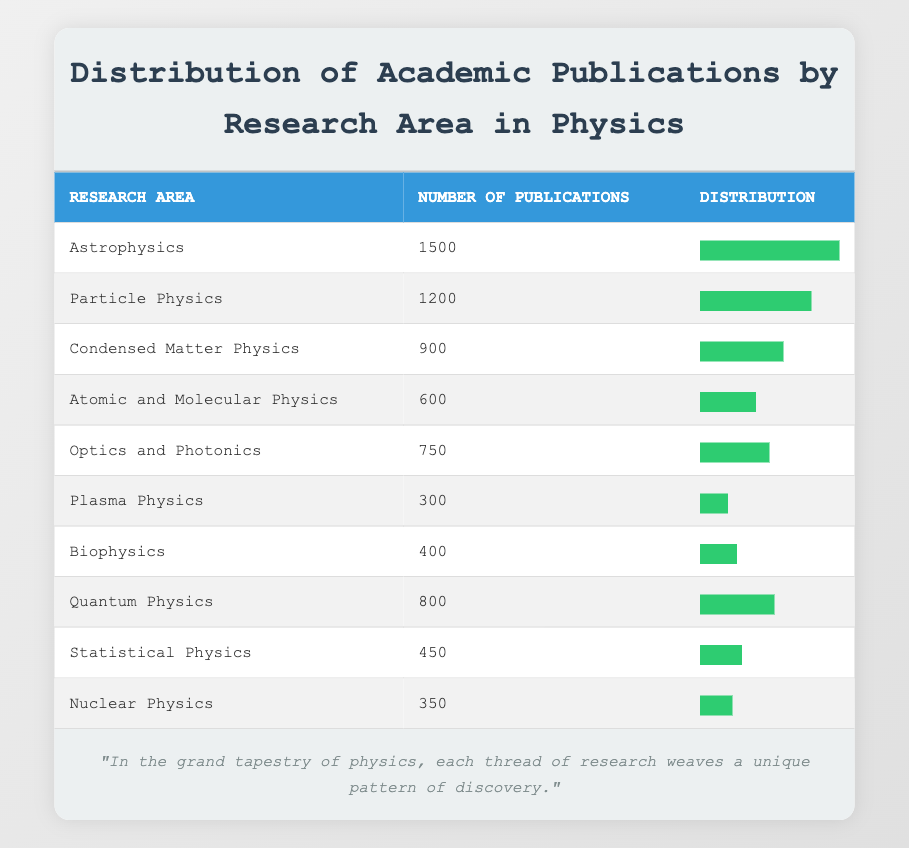What is the research area with the highest number of publications? The table clearly lists the research areas along with their publication numbers. Looking at the data, Astrophysics has 1500 publications, which is the highest compared to other areas.
Answer: Astrophysics How many publications does Nuclear Physics have? The table shows that Nuclear Physics has 350 publications listed in the second column corresponding to its research area.
Answer: 350 What is the total number of publications in the areas of Quantum Physics and Atomic and Molecular Physics? To find the total, we add the number of publications in Quantum Physics (800) and Atomic and Molecular Physics (600). So, 800 + 600 = 1400.
Answer: 1400 Is there more research in Particle Physics than in Plasma Physics? Particle Physics has 1200 publications, while Plasma Physics has only 300. Since 1200 is greater than 300, the statement is true.
Answer: Yes What is the average number of publications across the ten research areas listed? First, sum the number of publications for all areas: 1500 + 1200 + 900 + 600 + 750 + 300 + 400 + 800 + 450 + 350 = 6650. Then divide by the number of areas (10): 6650 / 10 = 665.
Answer: 665 Which research area has the least number of publications? The table shows Plasma Physics with 300 publications as the least compared to the others.
Answer: Plasma Physics Does the number of publications in Biophysics exceed 400? The table indicates that Biophysics has 400 publications, which does not exceed 400, so the answer is that the statement is false.
Answer: No What are the total publications in Condensed Matter Physics and Quantum Physics combined? We add the publications for Condensed Matter Physics (900) and Quantum Physics (800): 900 + 800 = 1700.
Answer: 1700 Which research area has a publication number that is less than the average publication count? The average number of publications is 665. Analyzing the table, areas like Plasma Physics (300), Biophysics (400), and Nuclear Physics (350) have fewer publications than the average.
Answer: Plasma Physics, Biophysics, Nuclear Physics 